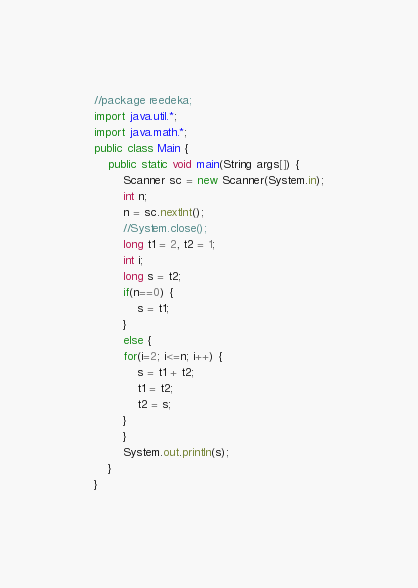Convert code to text. <code><loc_0><loc_0><loc_500><loc_500><_Java_>//package reedeka;
import java.util.*;
import java.math.*;
public class Main {
	public static void main(String args[]) {
		Scanner sc = new Scanner(System.in);
		int n;
		n = sc.nextInt();
		//System.close();
		long t1 = 2, t2 = 1;
		int i;
		long s = t2;
		if(n==0) {
			s = t1;
		}
		else {
		for(i=2; i<=n; i++) {
			s = t1 + t2;
			t1 = t2;
			t2 = s;
		}
		}
		System.out.println(s);
	}
}
</code> 